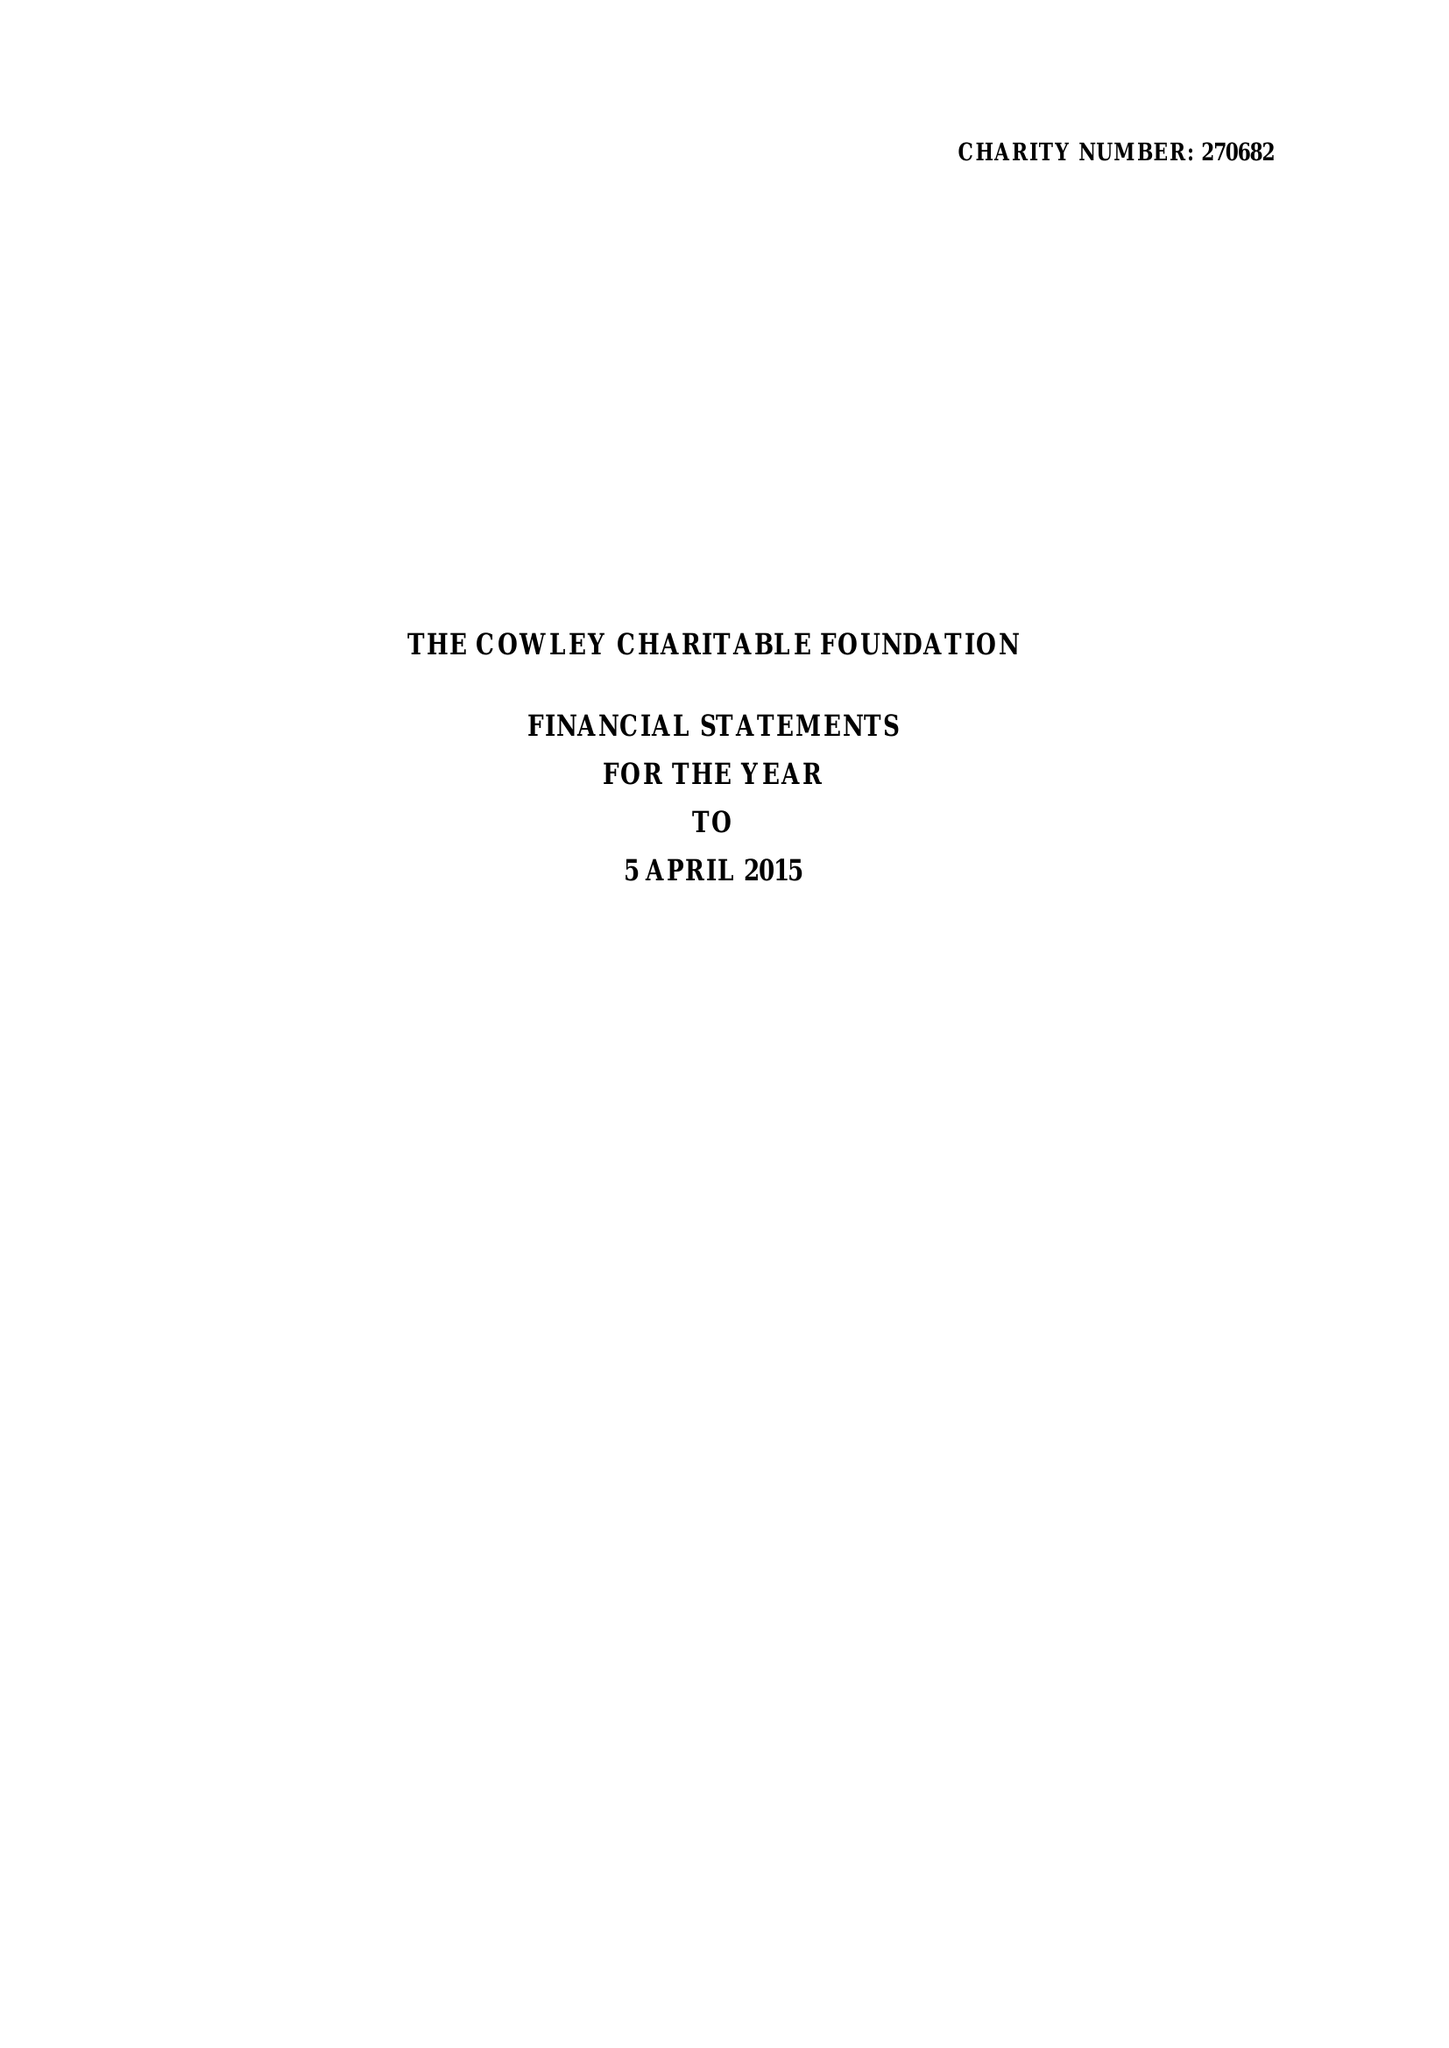What is the value for the income_annually_in_british_pounds?
Answer the question using a single word or phrase. 35879.00 